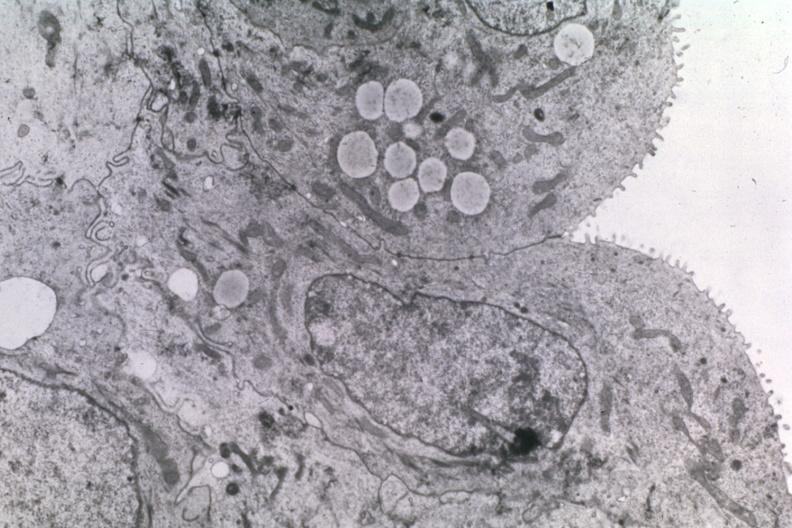what is present?
Answer the question using a single word or phrase. Metastatic carcinoma 